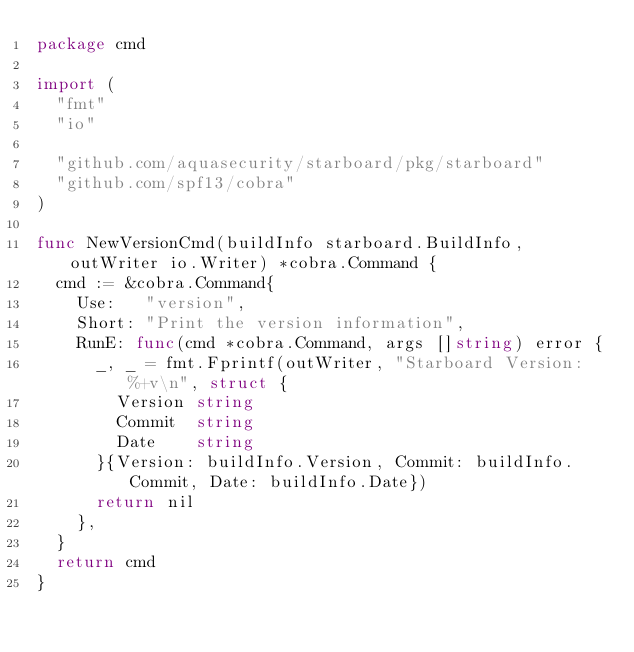Convert code to text. <code><loc_0><loc_0><loc_500><loc_500><_Go_>package cmd

import (
	"fmt"
	"io"

	"github.com/aquasecurity/starboard/pkg/starboard"
	"github.com/spf13/cobra"
)

func NewVersionCmd(buildInfo starboard.BuildInfo, outWriter io.Writer) *cobra.Command {
	cmd := &cobra.Command{
		Use:   "version",
		Short: "Print the version information",
		RunE: func(cmd *cobra.Command, args []string) error {
			_, _ = fmt.Fprintf(outWriter, "Starboard Version: %+v\n", struct {
				Version string
				Commit  string
				Date    string
			}{Version: buildInfo.Version, Commit: buildInfo.Commit, Date: buildInfo.Date})
			return nil
		},
	}
	return cmd
}
</code> 